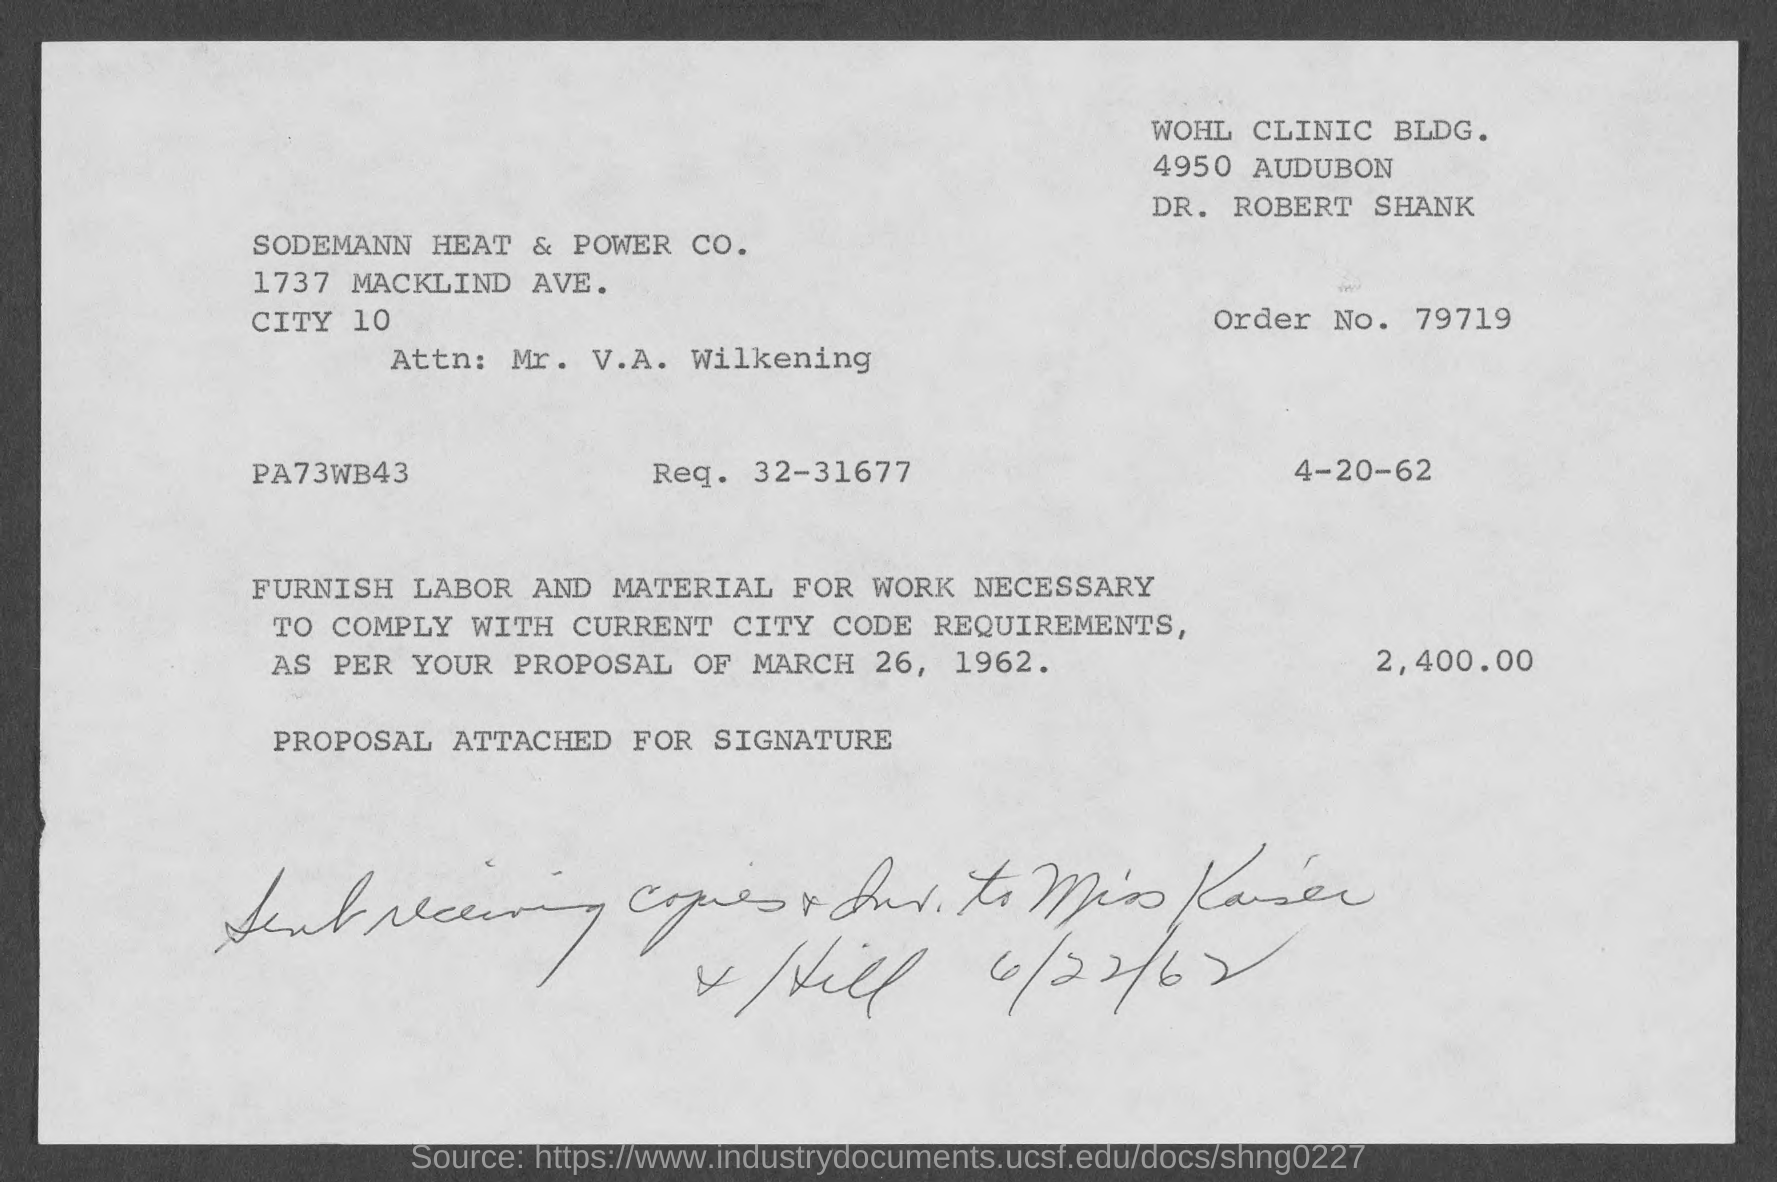What is the order no.?
Make the answer very short. 79719. 